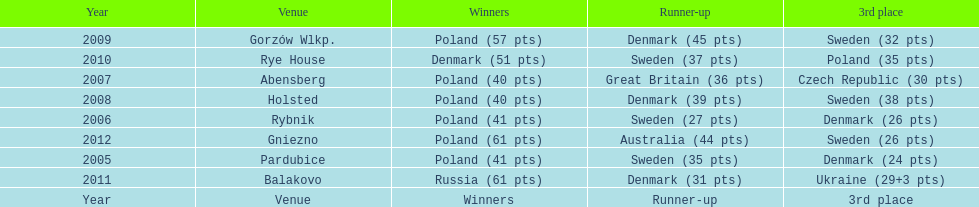After 2008 how many points total were scored by winners? 230. 